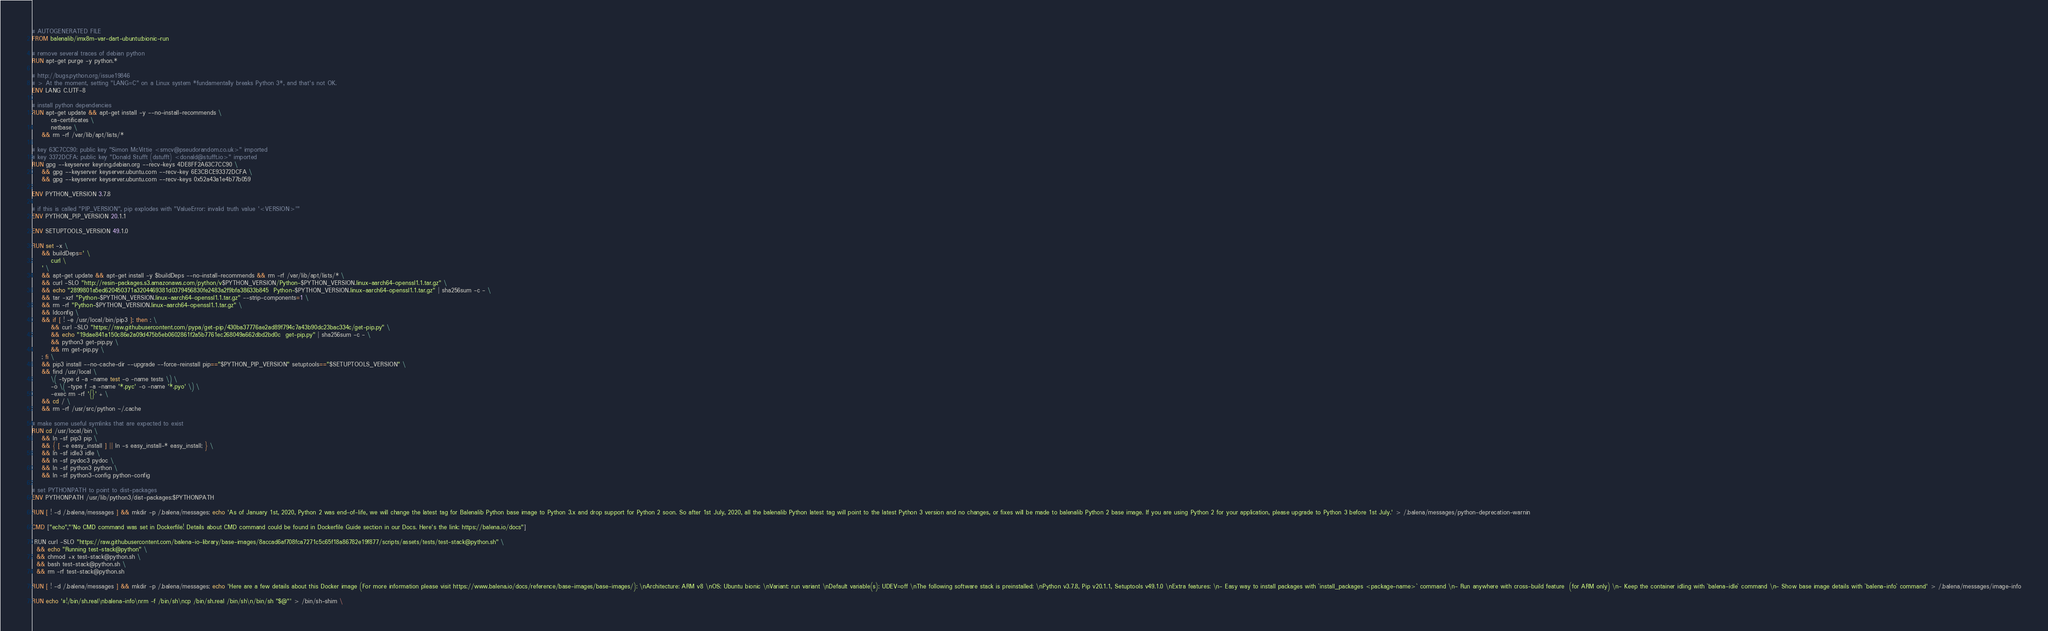<code> <loc_0><loc_0><loc_500><loc_500><_Dockerfile_># AUTOGENERATED FILE
FROM balenalib/imx8m-var-dart-ubuntu:bionic-run

# remove several traces of debian python
RUN apt-get purge -y python.*

# http://bugs.python.org/issue19846
# > At the moment, setting "LANG=C" on a Linux system *fundamentally breaks Python 3*, and that's not OK.
ENV LANG C.UTF-8

# install python dependencies
RUN apt-get update && apt-get install -y --no-install-recommends \
		ca-certificates \
		netbase \
	&& rm -rf /var/lib/apt/lists/*

# key 63C7CC90: public key "Simon McVittie <smcv@pseudorandom.co.uk>" imported
# key 3372DCFA: public key "Donald Stufft (dstufft) <donald@stufft.io>" imported
RUN gpg --keyserver keyring.debian.org --recv-keys 4DE8FF2A63C7CC90 \
	&& gpg --keyserver keyserver.ubuntu.com --recv-key 6E3CBCE93372DCFA \
	&& gpg --keyserver keyserver.ubuntu.com --recv-keys 0x52a43a1e4b77b059

ENV PYTHON_VERSION 3.7.8

# if this is called "PIP_VERSION", pip explodes with "ValueError: invalid truth value '<VERSION>'"
ENV PYTHON_PIP_VERSION 20.1.1

ENV SETUPTOOLS_VERSION 49.1.0

RUN set -x \
	&& buildDeps=' \
		curl \
	' \
	&& apt-get update && apt-get install -y $buildDeps --no-install-recommends && rm -rf /var/lib/apt/lists/* \
	&& curl -SLO "http://resin-packages.s3.amazonaws.com/python/v$PYTHON_VERSION/Python-$PYTHON_VERSION.linux-aarch64-openssl1.1.tar.gz" \
	&& echo "2899801a5ed620450371a3204469381d0379456830fe2483a2f9bfa38633b845  Python-$PYTHON_VERSION.linux-aarch64-openssl1.1.tar.gz" | sha256sum -c - \
	&& tar -xzf "Python-$PYTHON_VERSION.linux-aarch64-openssl1.1.tar.gz" --strip-components=1 \
	&& rm -rf "Python-$PYTHON_VERSION.linux-aarch64-openssl1.1.tar.gz" \
	&& ldconfig \
	&& if [ ! -e /usr/local/bin/pip3 ]; then : \
		&& curl -SLO "https://raw.githubusercontent.com/pypa/get-pip/430ba37776ae2ad89f794c7a43b90dc23bac334c/get-pip.py" \
		&& echo "19dae841a150c86e2a09d475b5eb0602861f2a5b7761ec268049a662dbd2bd0c  get-pip.py" | sha256sum -c - \
		&& python3 get-pip.py \
		&& rm get-pip.py \
	; fi \
	&& pip3 install --no-cache-dir --upgrade --force-reinstall pip=="$PYTHON_PIP_VERSION" setuptools=="$SETUPTOOLS_VERSION" \
	&& find /usr/local \
		\( -type d -a -name test -o -name tests \) \
		-o \( -type f -a -name '*.pyc' -o -name '*.pyo' \) \
		-exec rm -rf '{}' + \
	&& cd / \
	&& rm -rf /usr/src/python ~/.cache

# make some useful symlinks that are expected to exist
RUN cd /usr/local/bin \
	&& ln -sf pip3 pip \
	&& { [ -e easy_install ] || ln -s easy_install-* easy_install; } \
	&& ln -sf idle3 idle \
	&& ln -sf pydoc3 pydoc \
	&& ln -sf python3 python \
	&& ln -sf python3-config python-config

# set PYTHONPATH to point to dist-packages
ENV PYTHONPATH /usr/lib/python3/dist-packages:$PYTHONPATH

RUN [ ! -d /.balena/messages ] && mkdir -p /.balena/messages; echo 'As of January 1st, 2020, Python 2 was end-of-life, we will change the latest tag for Balenalib Python base image to Python 3.x and drop support for Python 2 soon. So after 1st July, 2020, all the balenalib Python latest tag will point to the latest Python 3 version and no changes, or fixes will be made to balenalib Python 2 base image. If you are using Python 2 for your application, please upgrade to Python 3 before 1st July.' > /.balena/messages/python-deprecation-warnin

CMD ["echo","'No CMD command was set in Dockerfile! Details about CMD command could be found in Dockerfile Guide section in our Docs. Here's the link: https://balena.io/docs"]

 RUN curl -SLO "https://raw.githubusercontent.com/balena-io-library/base-images/8accad6af708fca7271c5c65f18a86782e19f877/scripts/assets/tests/test-stack@python.sh" \
  && echo "Running test-stack@python" \
  && chmod +x test-stack@python.sh \
  && bash test-stack@python.sh \
  && rm -rf test-stack@python.sh 

RUN [ ! -d /.balena/messages ] && mkdir -p /.balena/messages; echo 'Here are a few details about this Docker image (For more information please visit https://www.balena.io/docs/reference/base-images/base-images/): \nArchitecture: ARM v8 \nOS: Ubuntu bionic \nVariant: run variant \nDefault variable(s): UDEV=off \nThe following software stack is preinstalled: \nPython v3.7.8, Pip v20.1.1, Setuptools v49.1.0 \nExtra features: \n- Easy way to install packages with `install_packages <package-name>` command \n- Run anywhere with cross-build feature  (for ARM only) \n- Keep the container idling with `balena-idle` command \n- Show base image details with `balena-info` command' > /.balena/messages/image-info

RUN echo '#!/bin/sh.real\nbalena-info\nrm -f /bin/sh\ncp /bin/sh.real /bin/sh\n/bin/sh "$@"' > /bin/sh-shim \</code> 